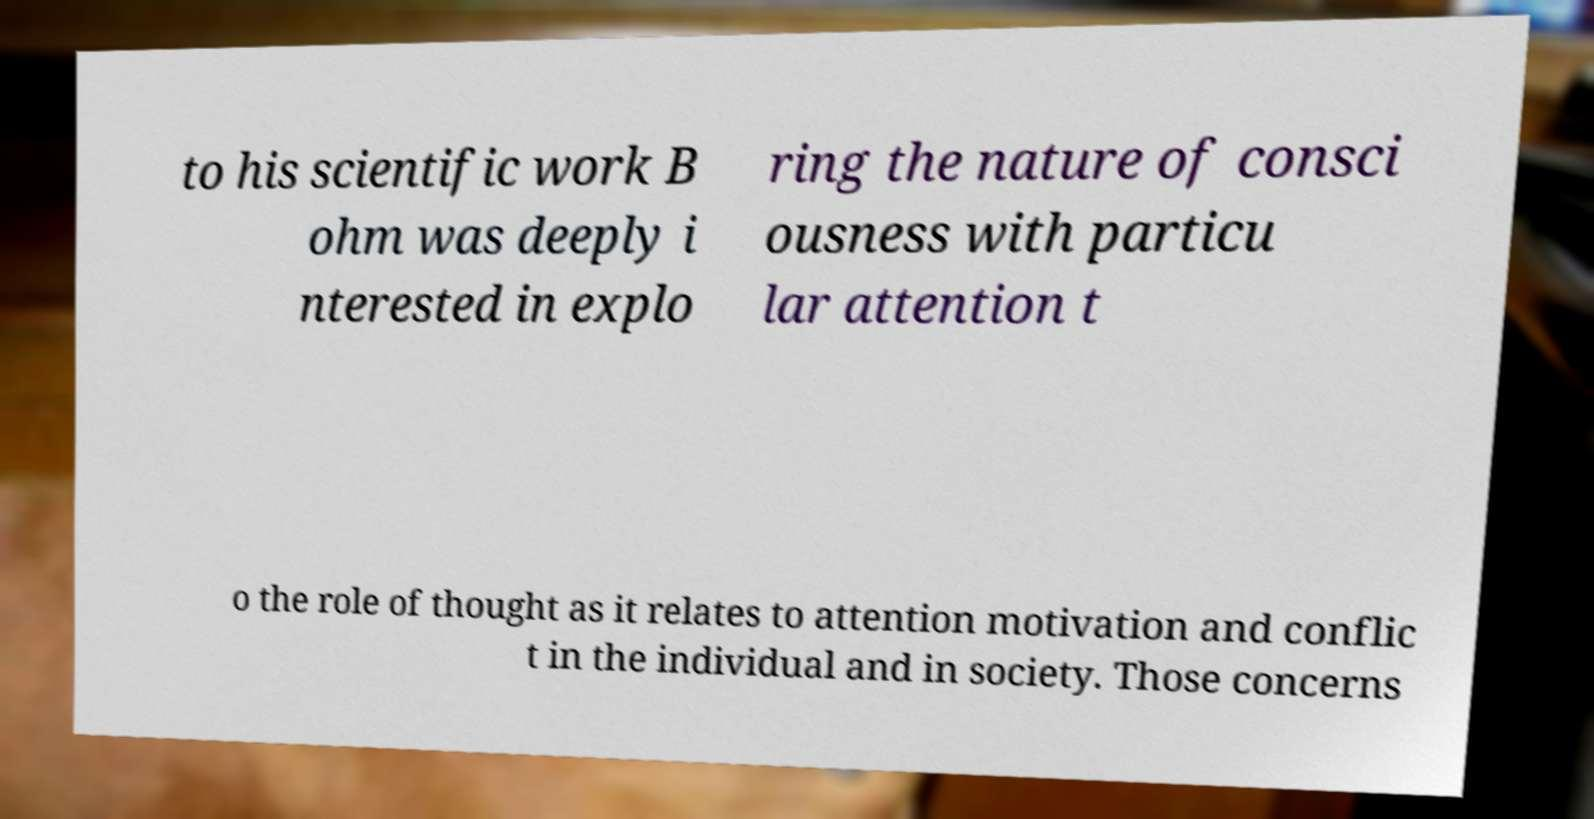I need the written content from this picture converted into text. Can you do that? to his scientific work B ohm was deeply i nterested in explo ring the nature of consci ousness with particu lar attention t o the role of thought as it relates to attention motivation and conflic t in the individual and in society. Those concerns 